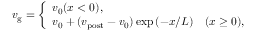Convert formula to latex. <formula><loc_0><loc_0><loc_500><loc_500>\begin{array} { r } { v _ { g } = \left \{ \begin{array} { l } { v _ { 0 } ( x < 0 ) , } \\ { v _ { 0 } + ( v _ { p o s t } - v _ { 0 } ) \exp { ( - x / L ) } \quad ( x \geq 0 ) , } \end{array} } \end{array}</formula> 